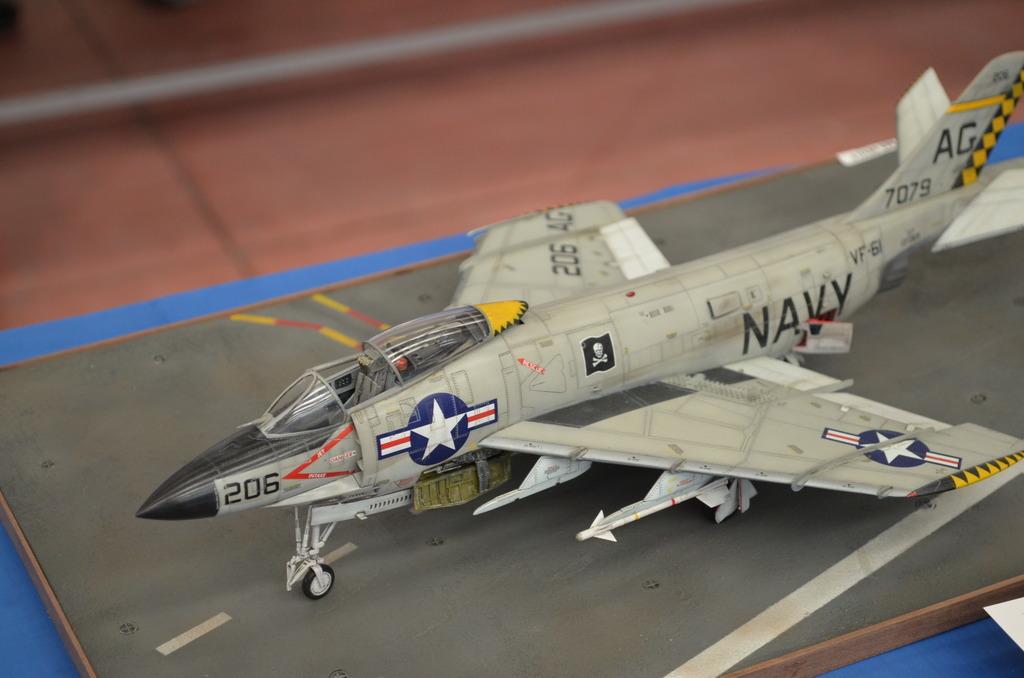What branch of the military does this plane belong to?
Your response must be concise. Navy. What is the number on the plane?
Offer a terse response. 206. 